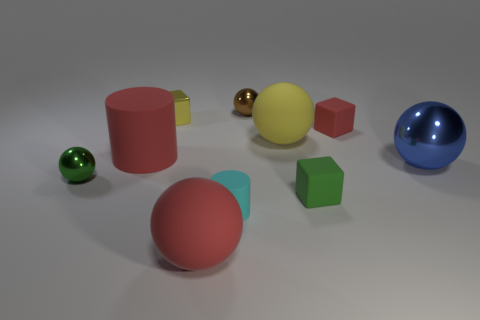There is a green cube; are there any tiny brown metal things behind it?
Provide a succinct answer. Yes. What is the shape of the big rubber object in front of the tiny block that is in front of the big yellow sphere?
Your answer should be very brief. Sphere. Is the number of large matte cylinders that are to the left of the big cylinder less than the number of spheres in front of the small green metal object?
Your response must be concise. Yes. There is a large metal thing that is the same shape as the tiny brown thing; what color is it?
Provide a short and direct response. Blue. What number of spheres are to the left of the red matte block and in front of the small red rubber cube?
Your answer should be very brief. 3. Are there more tiny blocks in front of the tiny yellow thing than tiny green shiny objects behind the large blue ball?
Give a very brief answer. Yes. What is the size of the blue metal sphere?
Offer a terse response. Large. Are there any other tiny matte objects of the same shape as the green rubber thing?
Ensure brevity in your answer.  Yes. Is the shape of the large yellow object the same as the small rubber object behind the big blue shiny thing?
Make the answer very short. No. What size is the red thing that is both to the left of the red block and to the right of the tiny yellow metallic object?
Offer a very short reply. Large. 